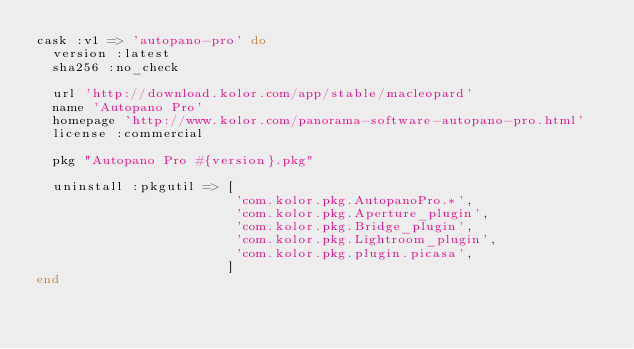Convert code to text. <code><loc_0><loc_0><loc_500><loc_500><_Ruby_>cask :v1 => 'autopano-pro' do
  version :latest
  sha256 :no_check

  url 'http://download.kolor.com/app/stable/macleopard'
  name 'Autopano Pro'
  homepage 'http://www.kolor.com/panorama-software-autopano-pro.html'
  license :commercial

  pkg "Autopano Pro #{version}.pkg"

  uninstall :pkgutil => [
                         'com.kolor.pkg.AutopanoPro.*',
                         'com.kolor.pkg.Aperture_plugin',
                         'com.kolor.pkg.Bridge_plugin',
                         'com.kolor.pkg.Lightroom_plugin',
                         'com.kolor.pkg.plugin.picasa',
                        ]
end
</code> 